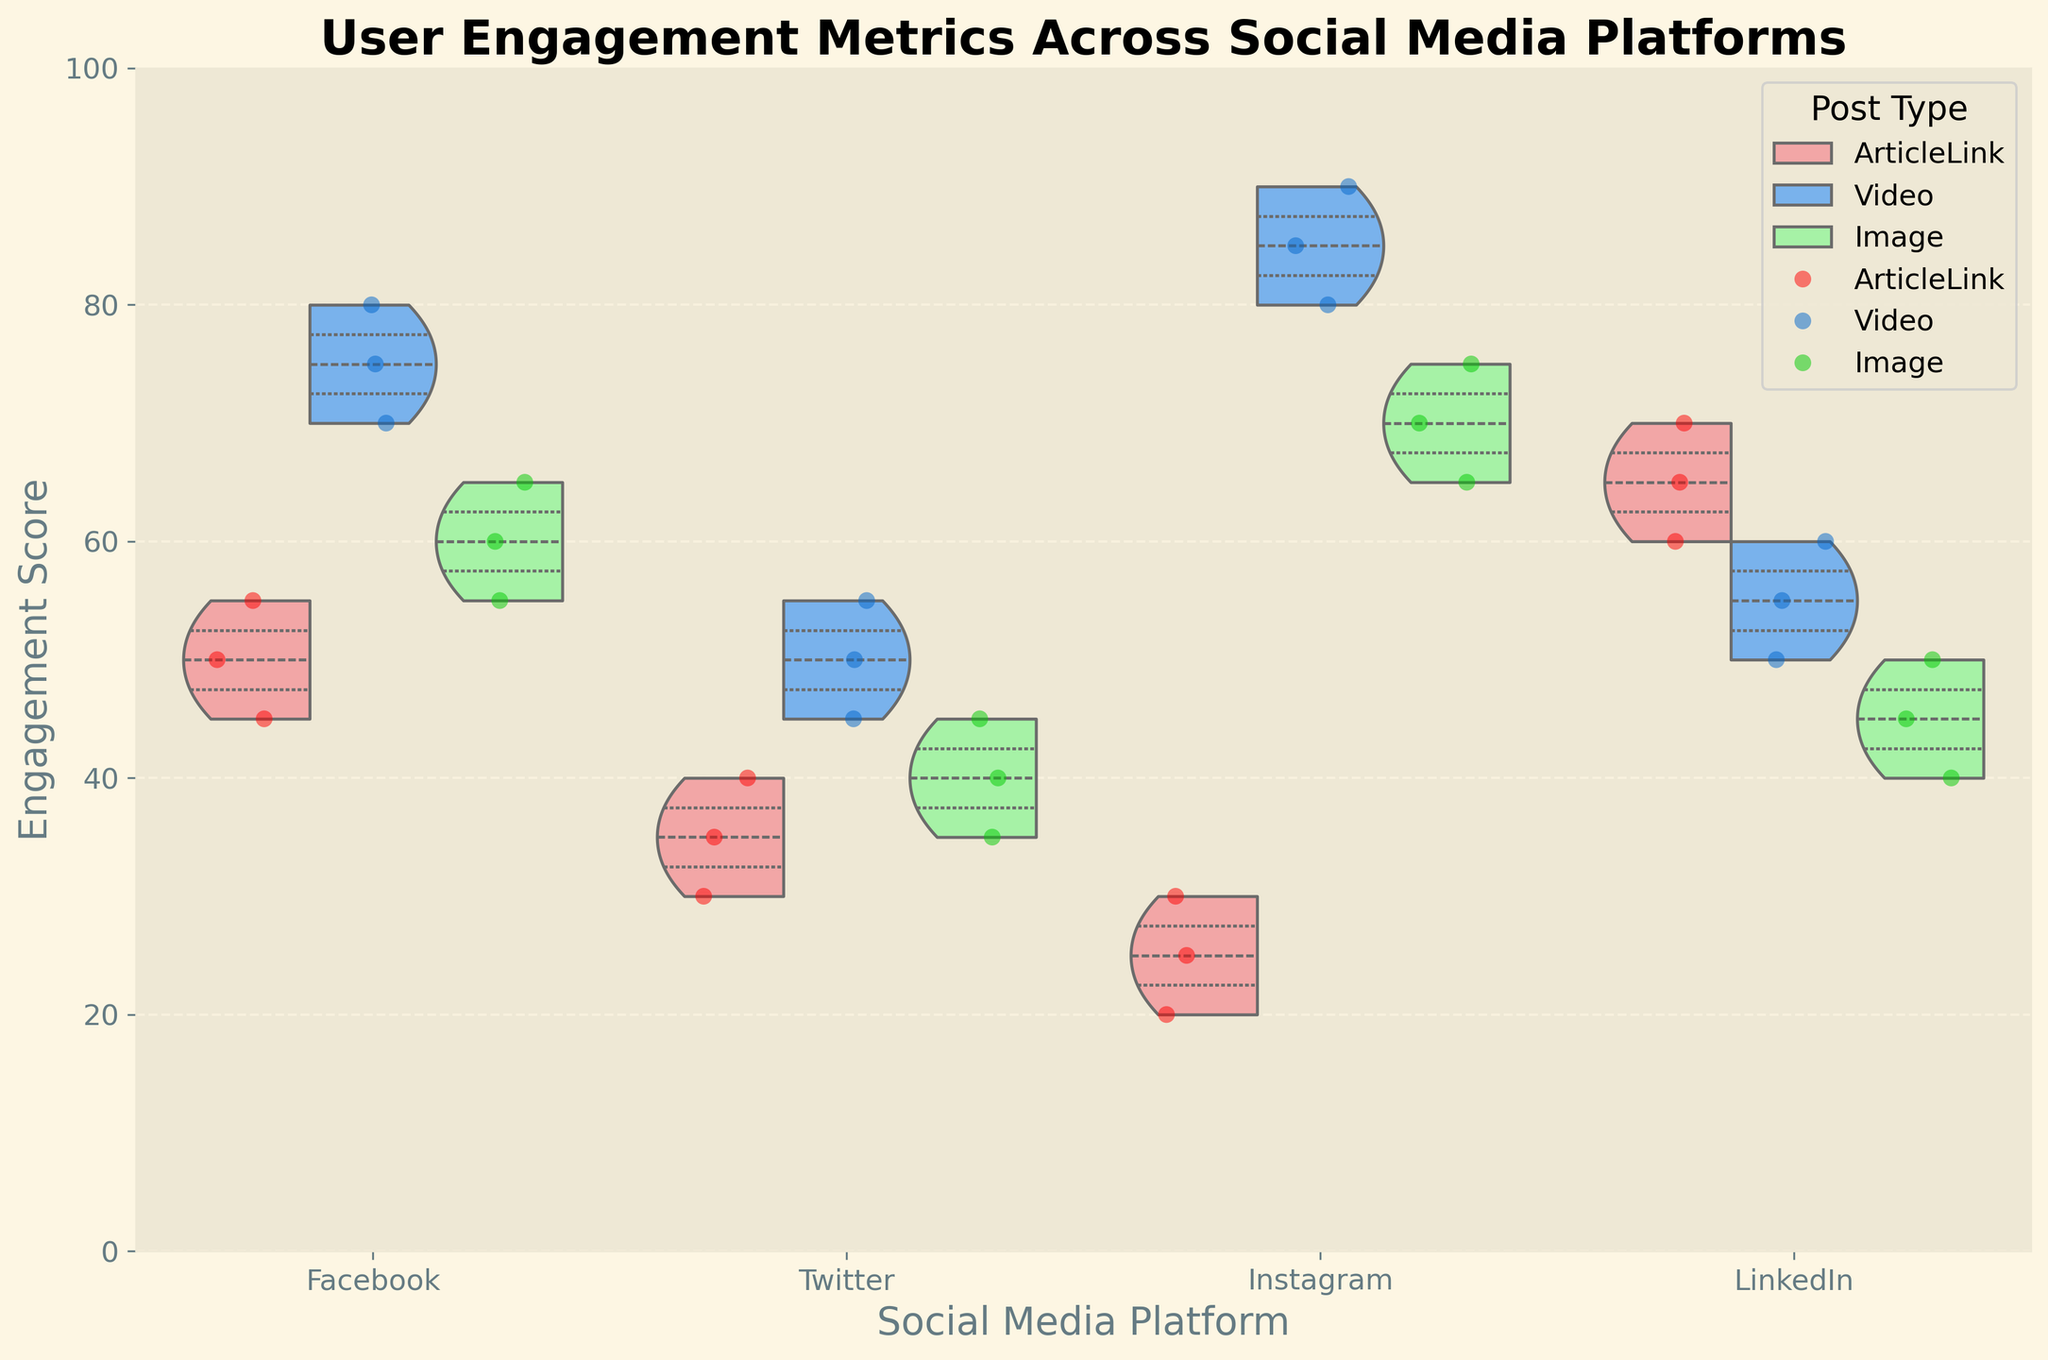What is the title of the figure? The title of the figure is displayed at the top in bold.
Answer: User Engagement Metrics Across Social Media Platforms Which social media platform has the highest engagement score for video posts? Look at the maximum peaks of the violin charts for video posts across all platforms. Instagram shows a peak at 90, the highest.
Answer: Instagram How does the engagement for image posts on Facebook compare to Twitter? Observe the range and density of the violin charts for image posts on both platforms. Facebook's range is roughly between 55 and 65, while Twitter's is between 35 and 45. Facebook generally has higher engagement for image posts.
Answer: Facebook has higher engagement What are the median engagement scores for article links on LinkedIn and Facebook? Look at the inner quartiles (white dot) in the violin plots for article links. LinkedIn's median is at 65, and Facebook's is roughly at 50.
Answer: LinkedIn: 65, Facebook: 50 Which post type shows the most variability in engagement scores on Twitter? Examine the width of the violin plots for each post type on Twitter. Article links have the widest range, indicating the highest variability.
Answer: ArticleLink How does the average engagement for video posts on Instagram compare to LinkedIn? Determine the density and central tendency within the violin plots for video posts. Instagram shows an average closer to 85, while LinkedIn centers around 55.
Answer: Instagram's average is higher Which post type tends to have the lowest engagement score on Instagram? Compare the lowest points of the violin plots for each post type on Instagram. Article links show the lowest point around 20.
Answer: ArticleLink Which platform and post type combination shows the least variability in engagement? Look for the narrowest violin plot across all combinations. Image posts on Facebook appear to have the least variability.
Answer: Facebook Image Are there any post types on any platform that show no overlap in their engagement score ranges? Check for any non-overlapping violin plots. On Instagram, video posts do not overlap with article links or image posts in their engagement scores.
Answer: Instagram Video What is the engagement score range for video posts on LinkedIn? Look at the range of the violin plot for video posts on LinkedIn. The range is from 50 to 60.
Answer: 50 to 60 